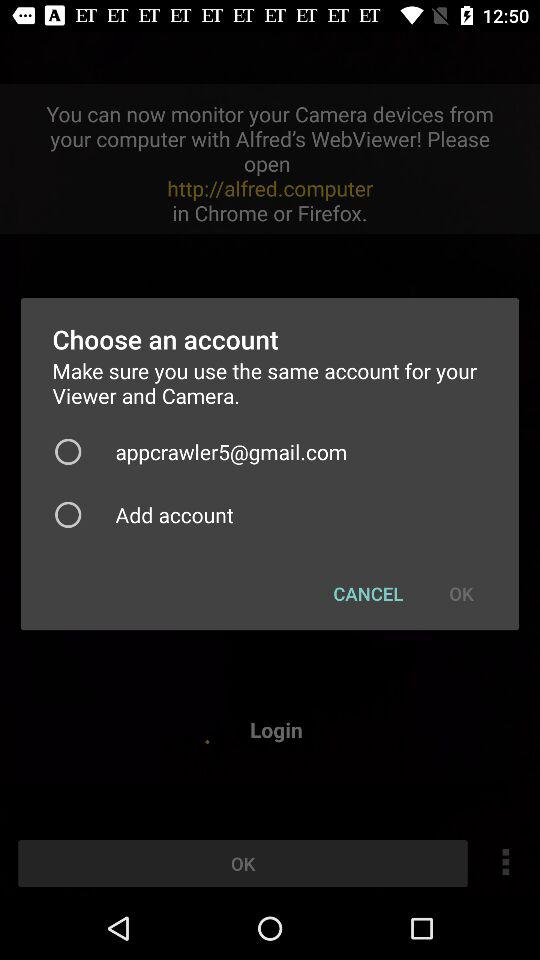What account is available to choose? The account is appcrawler5@gmail.com. 